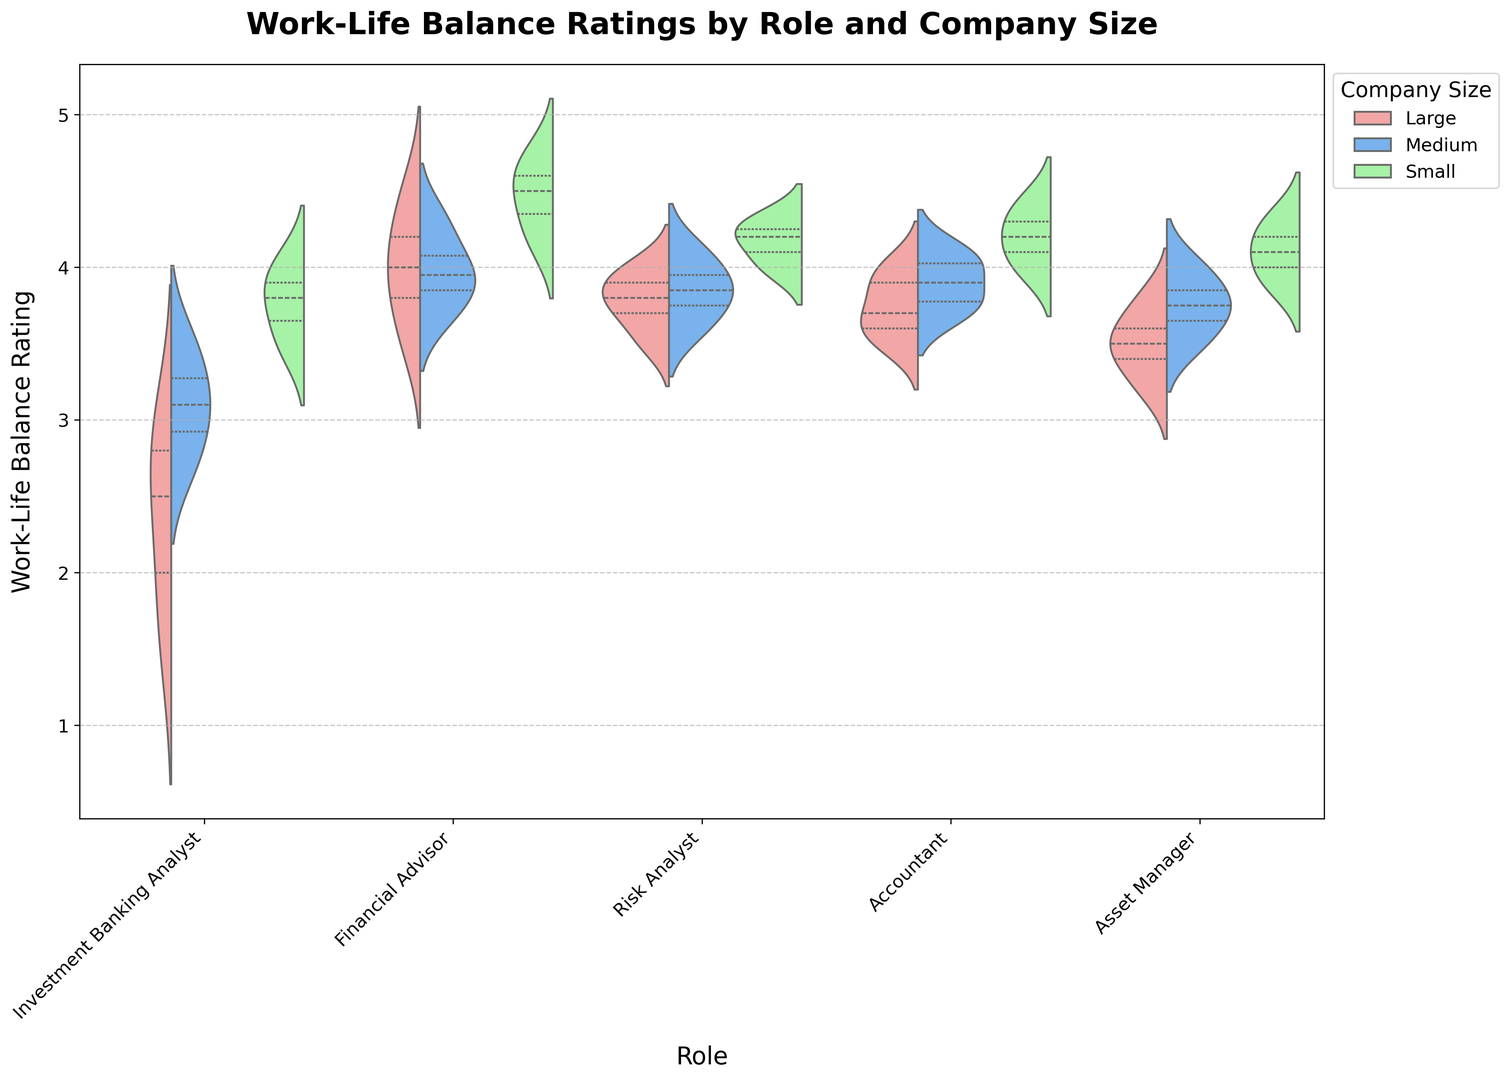Which role has the widest distribution of work-life balance ratings? The widest distribution can be identified by examining which violin plot spans the most extensive range of values. The Investment Banking Analyst role seems to show the widest distribution, especially for Large and Medium companies, ranging from approximately 1.5 to 4.0.
Answer: Investment Banking Analyst Which company size generally shows the highest work-life balance ratings across most roles? To identify this, we need to look at the central tendency of the distributions. Small companies seem to generally have their distributions centered higher compared to Large and Medium companies across different roles.
Answer: Small Do Financial Advisors in Large companies have a higher median work-life balance rating than Risk Analysts in Large companies? The median is represented by the thick central bar in the violin plot. Financial Advisors in Large companies have a median close to 4.0, whereas Risk Analysts in Large companies have a median around 3.8.
Answer: Yes Which role has the highest median work-life balance rating in Small companies? To find this, compare the central bar within the violin plots for Small companies across all roles. Financial Advisor displays the highest median rating among Small companies.
Answer: Financial Advisor Is the interquartile range (IQR) for Accountants in Medium companies greater than that for Asset Managers in Medium companies? The IQR can be assessed by looking at the distance between the innermost vertical lines in the violin plot. Accountants in Medium companies have a slightly wider IQR compared to Asset Managers in Medium companies.
Answer: Yes Which role has the least variability in work-life balance ratings within Small companies? Variability can be assessed by looking at the width of the violin plot. Risk Analysts and Accountants both have narrow plots, indicating low variability.
Answer: Risk Analyst or Accountant What is the approximate maximum work-life balance rating for Investment Banking Analysts in Large companies? The maximum rating for Investment Banking Analysts in Large companies can be observed towards the top of the violin plot, which is approximately 3.0.
Answer: 3.0 Compare the median work-life balance ratings of Investment Banking Analysts in Medium and Small companies. The median is indicated by the thick central line within each violin plot. Investment Banking Analysts in Small companies have a median rating closer to 3.8-4.0, while those in Medium companies have a median around 3.2-3.5.
Answer: Small companies have a higher median Does the work-life balance rating for Asset Managers in Large companies fall below 3.0? The bottom end of the violin plot for Asset Managers in Large companies almost touches 3.0 but does not fall below it.
Answer: No 